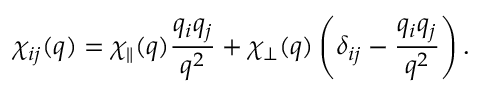<formula> <loc_0><loc_0><loc_500><loc_500>\chi _ { i j } ( q ) = \chi _ { \| } ( q ) \frac { q _ { i } q _ { j } } { q ^ { 2 } } + \chi _ { \perp } ( q ) \left ( \delta _ { i j } - \frac { q _ { i } q _ { j } } { q ^ { 2 } } \right ) .</formula> 